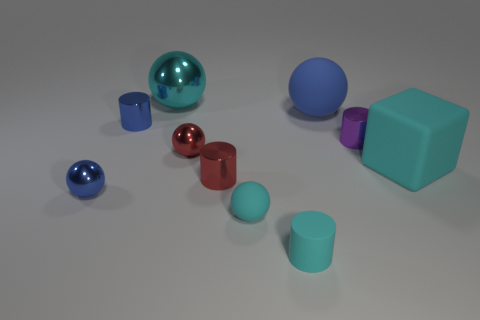Subtract all small blue shiny cylinders. How many cylinders are left? 3 Subtract all blue spheres. How many spheres are left? 3 Subtract all cylinders. How many objects are left? 6 Add 3 cyan cylinders. How many cyan cylinders exist? 4 Subtract 2 cyan spheres. How many objects are left? 8 Subtract 3 cylinders. How many cylinders are left? 1 Subtract all purple spheres. Subtract all yellow blocks. How many spheres are left? 5 Subtract all yellow blocks. How many green cylinders are left? 0 Subtract all small metallic things. Subtract all green shiny things. How many objects are left? 5 Add 5 cubes. How many cubes are left? 6 